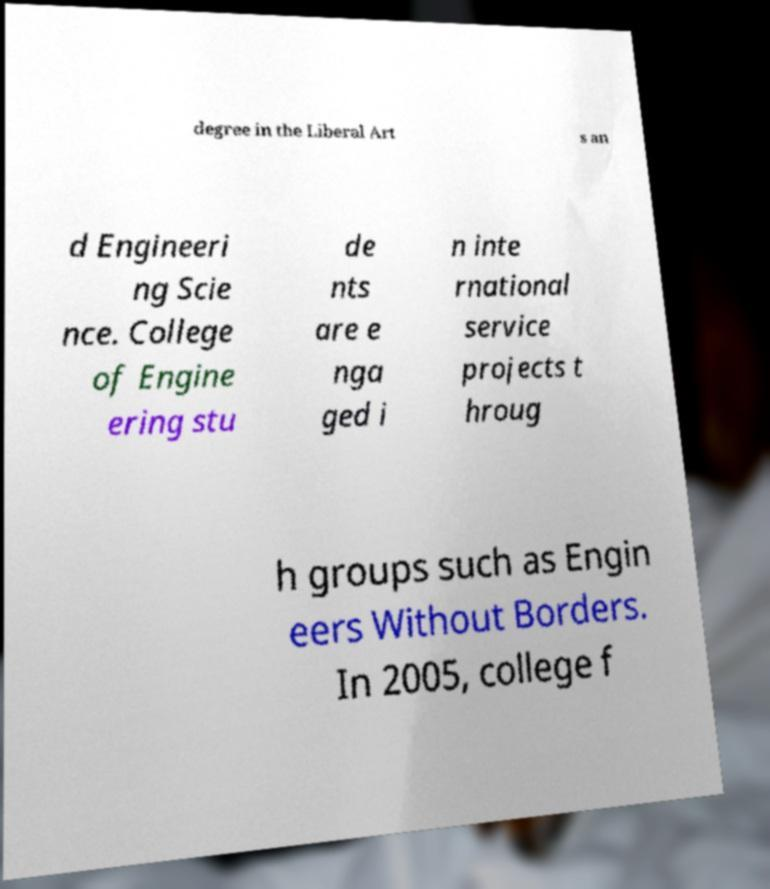For documentation purposes, I need the text within this image transcribed. Could you provide that? degree in the Liberal Art s an d Engineeri ng Scie nce. College of Engine ering stu de nts are e nga ged i n inte rnational service projects t hroug h groups such as Engin eers Without Borders. In 2005, college f 